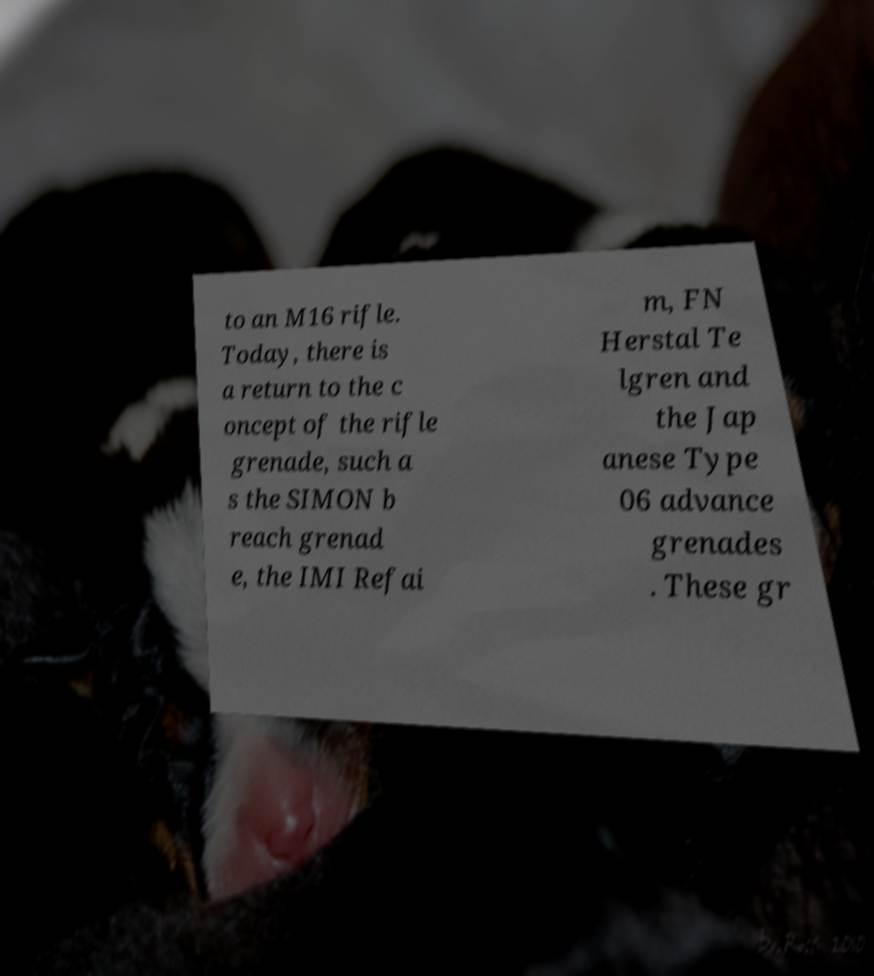Can you accurately transcribe the text from the provided image for me? to an M16 rifle. Today, there is a return to the c oncept of the rifle grenade, such a s the SIMON b reach grenad e, the IMI Refai m, FN Herstal Te lgren and the Jap anese Type 06 advance grenades . These gr 